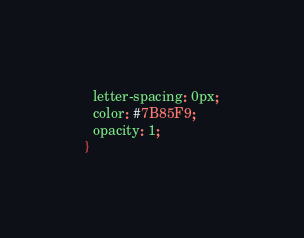<code> <loc_0><loc_0><loc_500><loc_500><_CSS_>  letter-spacing: 0px;
  color: #7B85F9;
  opacity: 1;
}</code> 